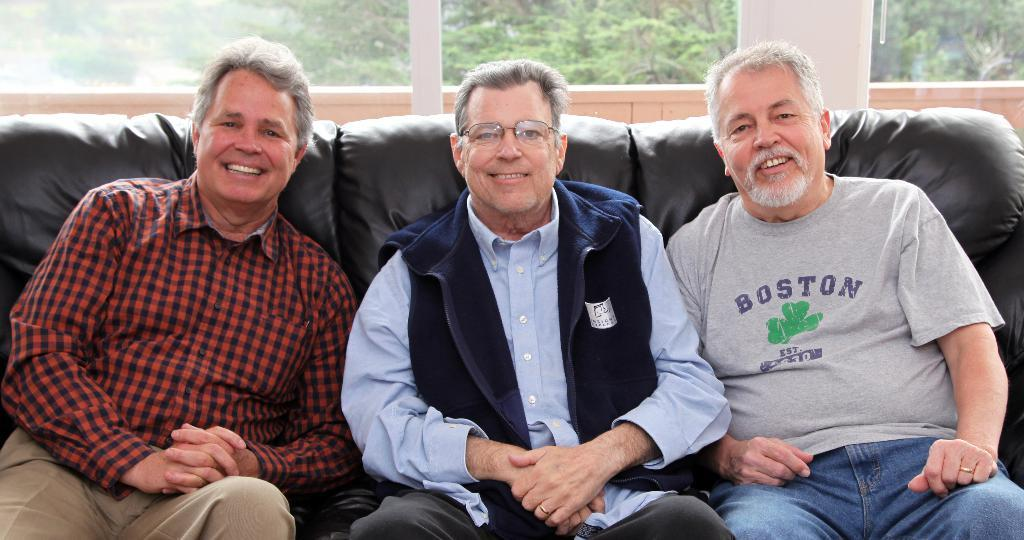How many people are in the image? There are three people in the image. What are the people doing in the image? The people are sitting on a sofa and smiling. What can be seen through the glass windows in the image? Trees are visible through the glass windows. What type of loaf is being prepared by the sister in the image? There is no sister or loaf present in the image. What type of crime is being committed in the image? There is no crime being committed in the image. 